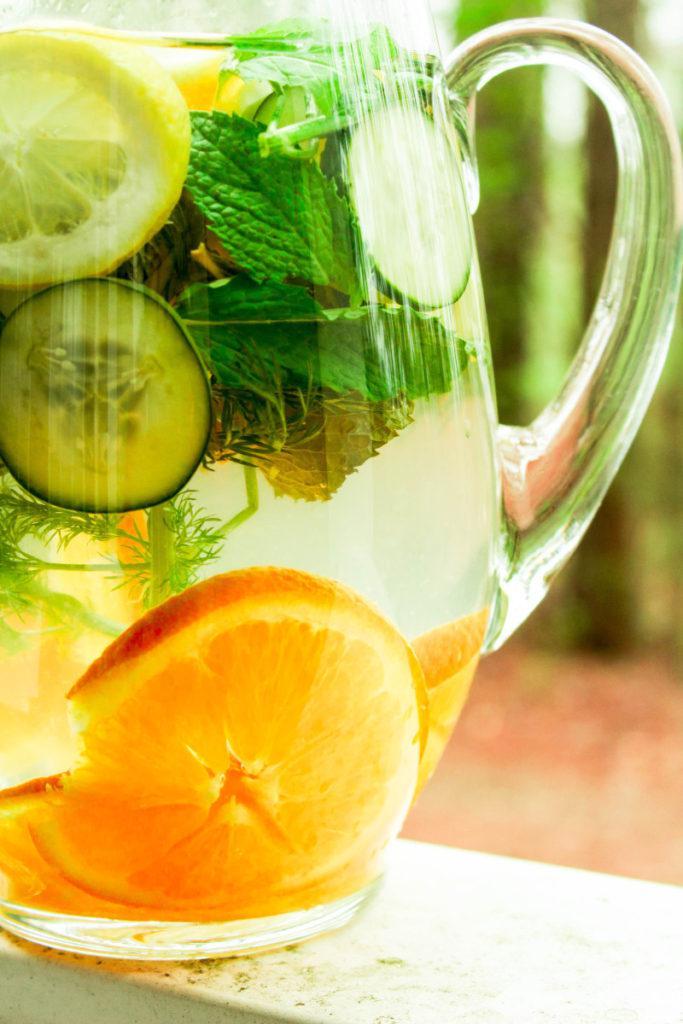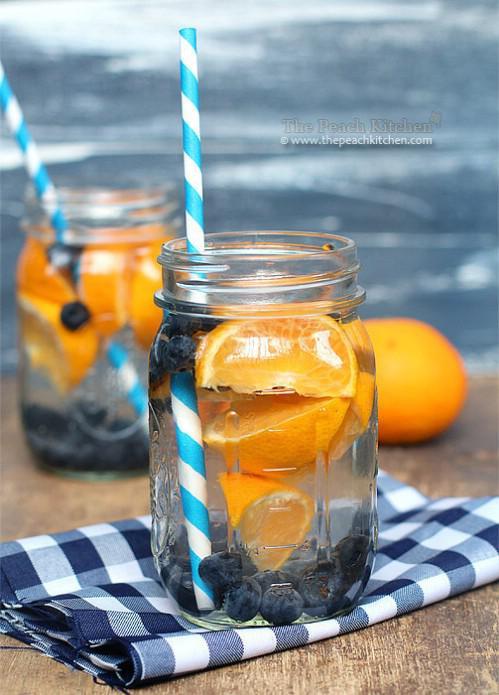The first image is the image on the left, the second image is the image on the right. Evaluate the accuracy of this statement regarding the images: "In one image, drinks are served in two mason jar glasses, one of them sitting on a cloth napkin, with striped straws.". Is it true? Answer yes or no. Yes. The first image is the image on the left, the second image is the image on the right. Evaluate the accuracy of this statement regarding the images: "An image shows a striped straw in a jar-type beverage glass.". Is it true? Answer yes or no. Yes. 